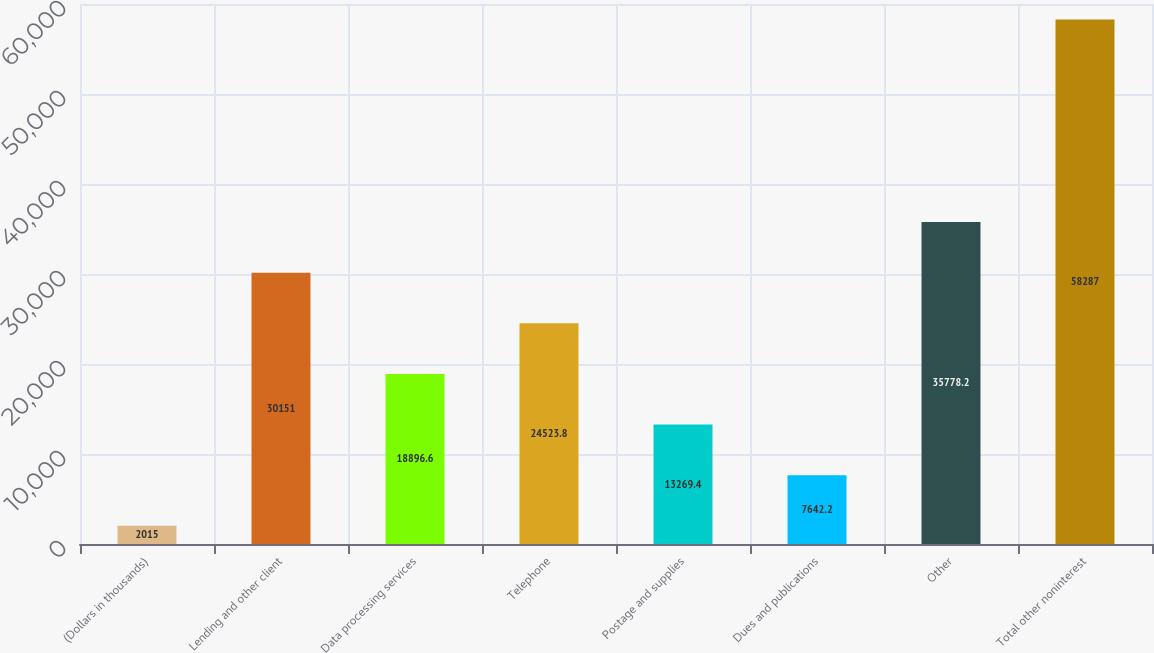Convert chart to OTSL. <chart><loc_0><loc_0><loc_500><loc_500><bar_chart><fcel>(Dollars in thousands)<fcel>Lending and other client<fcel>Data processing services<fcel>Telephone<fcel>Postage and supplies<fcel>Dues and publications<fcel>Other<fcel>Total other noninterest<nl><fcel>2015<fcel>30151<fcel>18896.6<fcel>24523.8<fcel>13269.4<fcel>7642.2<fcel>35778.2<fcel>58287<nl></chart> 